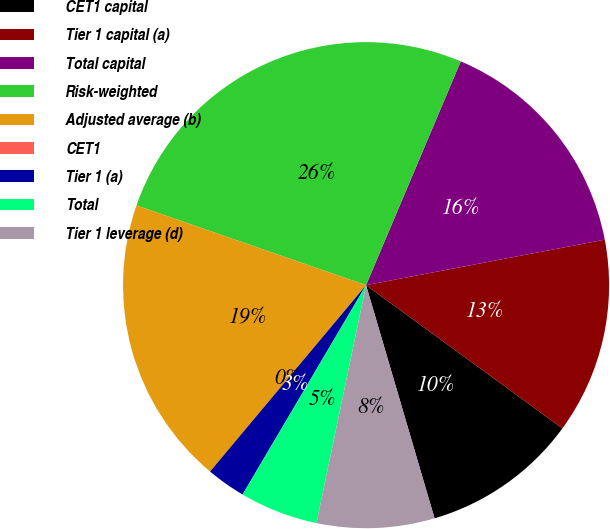<chart> <loc_0><loc_0><loc_500><loc_500><pie_chart><fcel>CET1 capital<fcel>Tier 1 capital (a)<fcel>Total capital<fcel>Risk-weighted<fcel>Adjusted average (b)<fcel>CET1<fcel>Tier 1 (a)<fcel>Total<fcel>Tier 1 leverage (d)<nl><fcel>10.42%<fcel>13.03%<fcel>15.63%<fcel>26.05%<fcel>19.23%<fcel>0.0%<fcel>2.61%<fcel>5.21%<fcel>7.82%<nl></chart> 